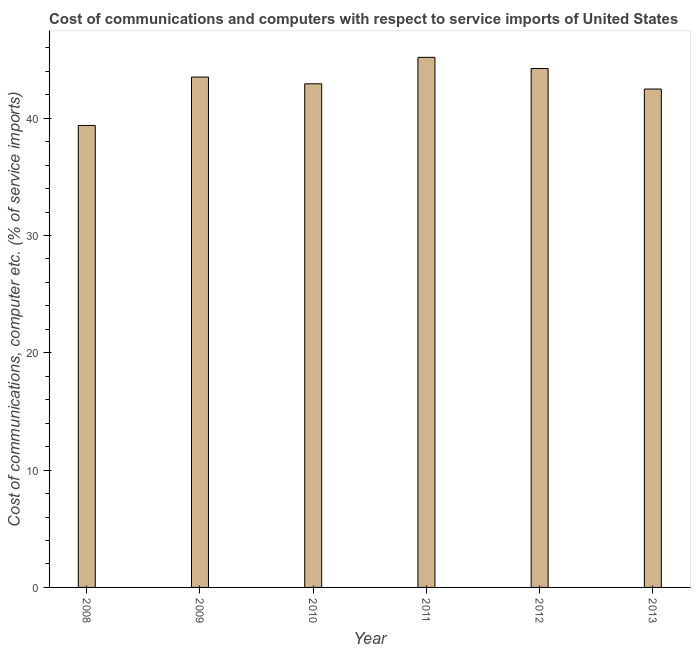Does the graph contain grids?
Offer a very short reply. No. What is the title of the graph?
Keep it short and to the point. Cost of communications and computers with respect to service imports of United States. What is the label or title of the Y-axis?
Your answer should be very brief. Cost of communications, computer etc. (% of service imports). What is the cost of communications and computer in 2009?
Ensure brevity in your answer.  43.51. Across all years, what is the maximum cost of communications and computer?
Provide a succinct answer. 45.19. Across all years, what is the minimum cost of communications and computer?
Your answer should be compact. 39.38. In which year was the cost of communications and computer maximum?
Provide a succinct answer. 2011. What is the sum of the cost of communications and computer?
Your answer should be compact. 257.74. What is the difference between the cost of communications and computer in 2009 and 2012?
Ensure brevity in your answer.  -0.73. What is the average cost of communications and computer per year?
Ensure brevity in your answer.  42.96. What is the median cost of communications and computer?
Ensure brevity in your answer.  43.22. Do a majority of the years between 2008 and 2009 (inclusive) have cost of communications and computer greater than 4 %?
Make the answer very short. Yes. What is the ratio of the cost of communications and computer in 2008 to that in 2011?
Your response must be concise. 0.87. Is the cost of communications and computer in 2008 less than that in 2013?
Your response must be concise. Yes. Is the difference between the cost of communications and computer in 2008 and 2012 greater than the difference between any two years?
Give a very brief answer. No. What is the difference between the highest and the second highest cost of communications and computer?
Your answer should be very brief. 0.95. Is the sum of the cost of communications and computer in 2011 and 2012 greater than the maximum cost of communications and computer across all years?
Offer a terse response. Yes. What is the difference between the highest and the lowest cost of communications and computer?
Your response must be concise. 5.81. In how many years, is the cost of communications and computer greater than the average cost of communications and computer taken over all years?
Your response must be concise. 3. How many years are there in the graph?
Make the answer very short. 6. Are the values on the major ticks of Y-axis written in scientific E-notation?
Provide a succinct answer. No. What is the Cost of communications, computer etc. (% of service imports) in 2008?
Make the answer very short. 39.38. What is the Cost of communications, computer etc. (% of service imports) in 2009?
Keep it short and to the point. 43.51. What is the Cost of communications, computer etc. (% of service imports) in 2010?
Give a very brief answer. 42.93. What is the Cost of communications, computer etc. (% of service imports) of 2011?
Offer a terse response. 45.19. What is the Cost of communications, computer etc. (% of service imports) in 2012?
Your answer should be compact. 44.24. What is the Cost of communications, computer etc. (% of service imports) in 2013?
Your answer should be compact. 42.49. What is the difference between the Cost of communications, computer etc. (% of service imports) in 2008 and 2009?
Offer a terse response. -4.12. What is the difference between the Cost of communications, computer etc. (% of service imports) in 2008 and 2010?
Ensure brevity in your answer.  -3.55. What is the difference between the Cost of communications, computer etc. (% of service imports) in 2008 and 2011?
Give a very brief answer. -5.81. What is the difference between the Cost of communications, computer etc. (% of service imports) in 2008 and 2012?
Ensure brevity in your answer.  -4.85. What is the difference between the Cost of communications, computer etc. (% of service imports) in 2008 and 2013?
Offer a terse response. -3.1. What is the difference between the Cost of communications, computer etc. (% of service imports) in 2009 and 2010?
Offer a very short reply. 0.57. What is the difference between the Cost of communications, computer etc. (% of service imports) in 2009 and 2011?
Offer a very short reply. -1.68. What is the difference between the Cost of communications, computer etc. (% of service imports) in 2009 and 2012?
Provide a succinct answer. -0.73. What is the difference between the Cost of communications, computer etc. (% of service imports) in 2009 and 2013?
Provide a succinct answer. 1.02. What is the difference between the Cost of communications, computer etc. (% of service imports) in 2010 and 2011?
Provide a short and direct response. -2.26. What is the difference between the Cost of communications, computer etc. (% of service imports) in 2010 and 2012?
Provide a succinct answer. -1.3. What is the difference between the Cost of communications, computer etc. (% of service imports) in 2010 and 2013?
Offer a terse response. 0.45. What is the difference between the Cost of communications, computer etc. (% of service imports) in 2011 and 2012?
Keep it short and to the point. 0.95. What is the difference between the Cost of communications, computer etc. (% of service imports) in 2011 and 2013?
Offer a very short reply. 2.7. What is the difference between the Cost of communications, computer etc. (% of service imports) in 2012 and 2013?
Offer a very short reply. 1.75. What is the ratio of the Cost of communications, computer etc. (% of service imports) in 2008 to that in 2009?
Your response must be concise. 0.91. What is the ratio of the Cost of communications, computer etc. (% of service imports) in 2008 to that in 2010?
Your answer should be very brief. 0.92. What is the ratio of the Cost of communications, computer etc. (% of service imports) in 2008 to that in 2011?
Offer a terse response. 0.87. What is the ratio of the Cost of communications, computer etc. (% of service imports) in 2008 to that in 2012?
Your answer should be very brief. 0.89. What is the ratio of the Cost of communications, computer etc. (% of service imports) in 2008 to that in 2013?
Keep it short and to the point. 0.93. What is the ratio of the Cost of communications, computer etc. (% of service imports) in 2009 to that in 2010?
Give a very brief answer. 1.01. What is the ratio of the Cost of communications, computer etc. (% of service imports) in 2009 to that in 2012?
Provide a short and direct response. 0.98. What is the ratio of the Cost of communications, computer etc. (% of service imports) in 2010 to that in 2011?
Your answer should be very brief. 0.95. What is the ratio of the Cost of communications, computer etc. (% of service imports) in 2010 to that in 2012?
Give a very brief answer. 0.97. What is the ratio of the Cost of communications, computer etc. (% of service imports) in 2011 to that in 2012?
Your answer should be very brief. 1.02. What is the ratio of the Cost of communications, computer etc. (% of service imports) in 2011 to that in 2013?
Ensure brevity in your answer.  1.06. What is the ratio of the Cost of communications, computer etc. (% of service imports) in 2012 to that in 2013?
Ensure brevity in your answer.  1.04. 